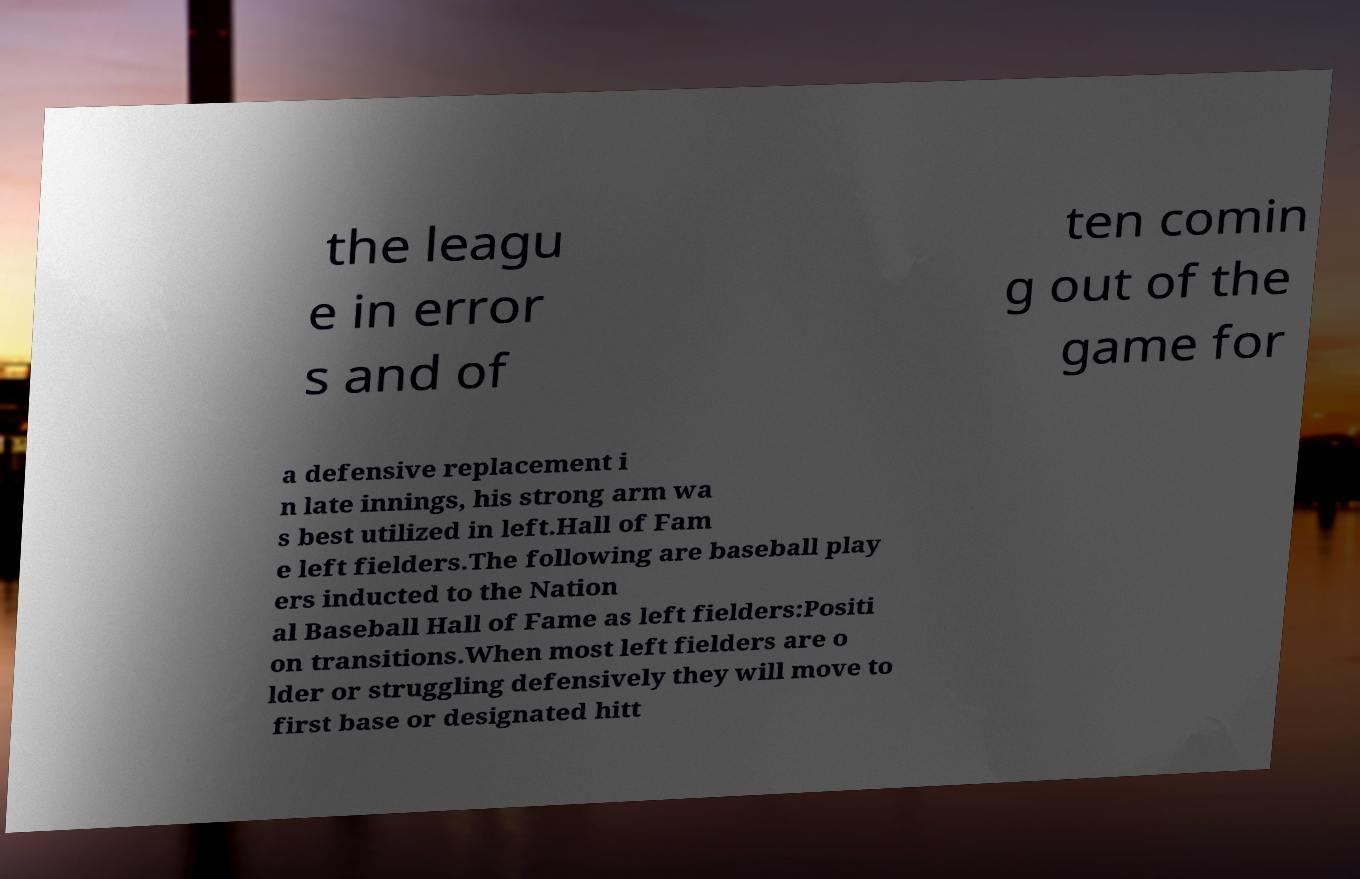I need the written content from this picture converted into text. Can you do that? the leagu e in error s and of ten comin g out of the game for a defensive replacement i n late innings, his strong arm wa s best utilized in left.Hall of Fam e left fielders.The following are baseball play ers inducted to the Nation al Baseball Hall of Fame as left fielders:Positi on transitions.When most left fielders are o lder or struggling defensively they will move to first base or designated hitt 